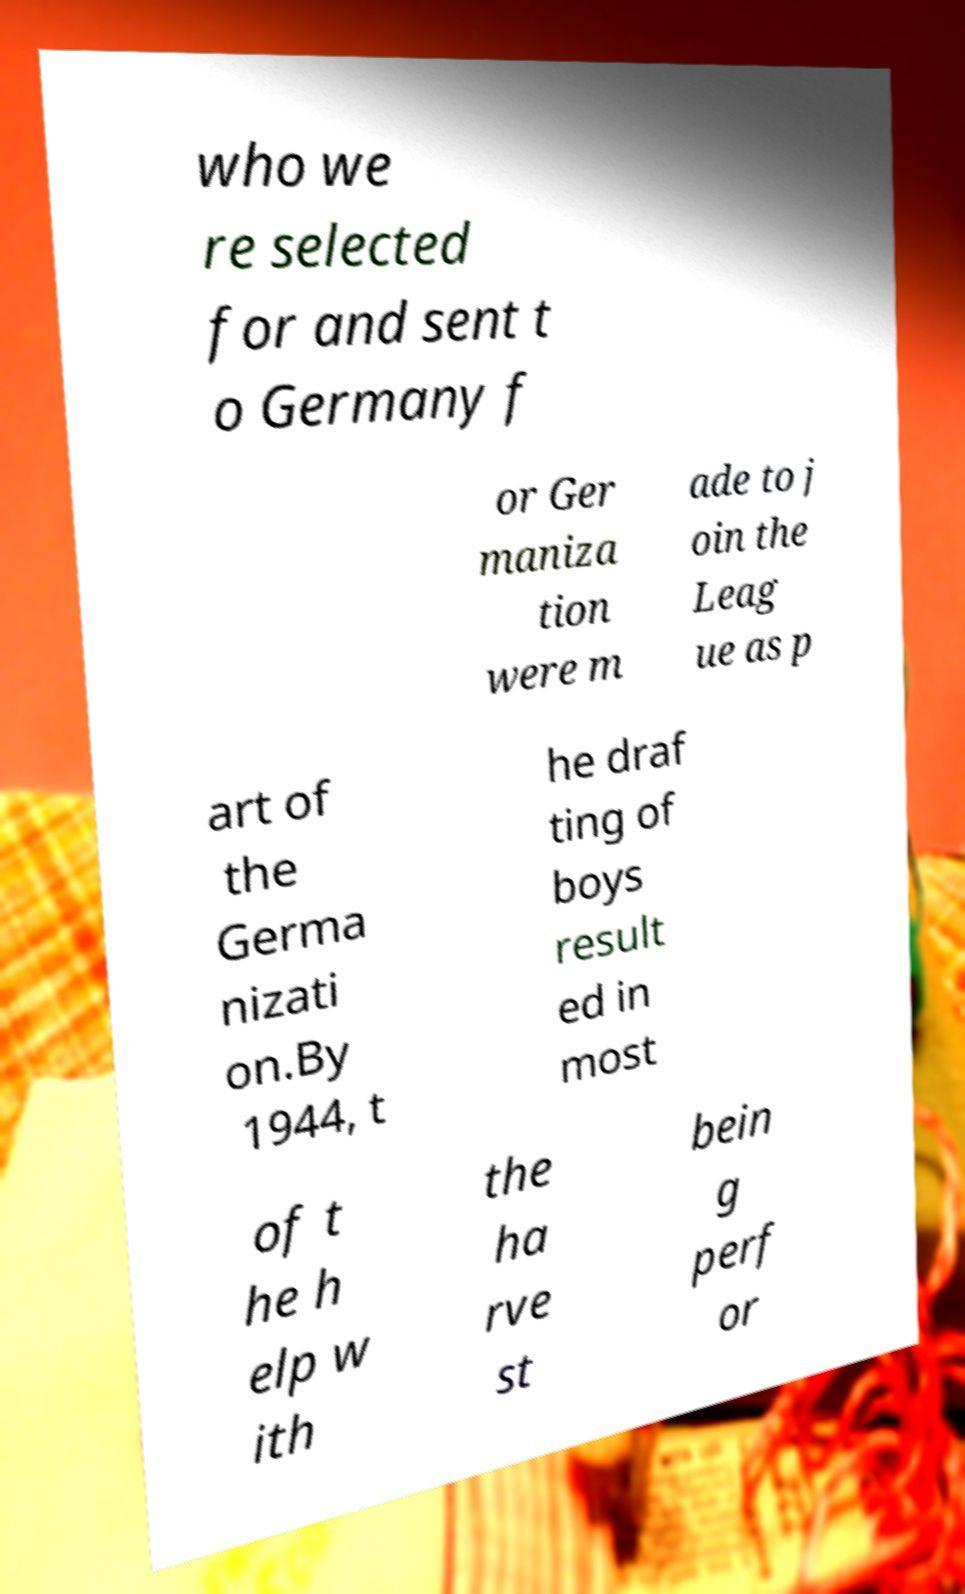There's text embedded in this image that I need extracted. Can you transcribe it verbatim? who we re selected for and sent t o Germany f or Ger maniza tion were m ade to j oin the Leag ue as p art of the Germa nizati on.By 1944, t he draf ting of boys result ed in most of t he h elp w ith the ha rve st bein g perf or 